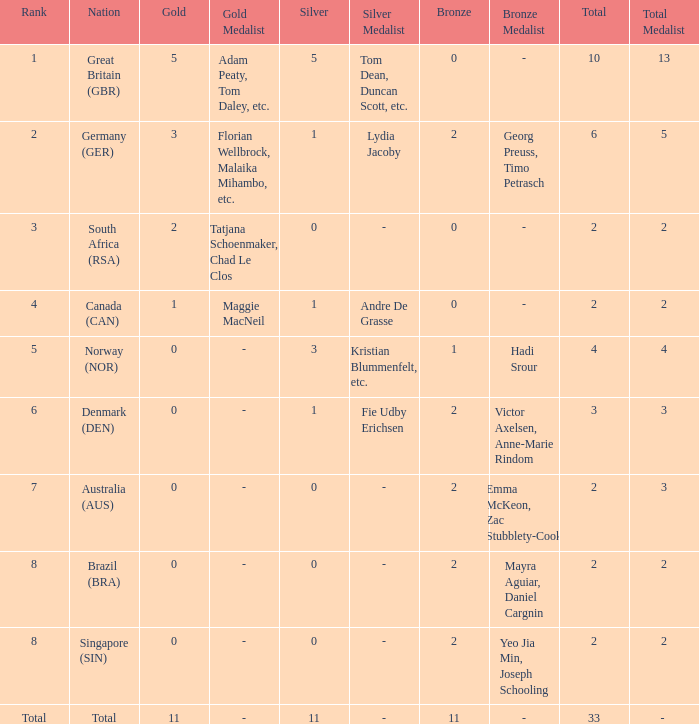Could you parse the entire table as a dict? {'header': ['Rank', 'Nation', 'Gold', 'Gold Medalist', 'Silver', 'Silver Medalist', 'Bronze', 'Bronze Medalist', 'Total', 'Total Medalist'], 'rows': [['1', 'Great Britain (GBR)', '5', 'Adam Peaty, Tom Daley, etc.', '5', 'Tom Dean, Duncan Scott, etc.', '0', '-', '10', '13'], ['2', 'Germany (GER)', '3', 'Florian Wellbrock, Malaika Mihambo, etc.', '1', 'Lydia Jacoby', '2', 'Georg Preuss, Timo Petrasch', '6', '5'], ['3', 'South Africa (RSA)', '2', 'Tatjana Schoenmaker, Chad Le Clos', '0', '-', '0', '-', '2', '2'], ['4', 'Canada (CAN)', '1', 'Maggie MacNeil', '1', 'Andre De Grasse', '0', '-', '2', '2'], ['5', 'Norway (NOR)', '0', '-', '3', 'Kristian Blummenfelt, etc.', '1', 'Hadi Srour', '4', '4'], ['6', 'Denmark (DEN)', '0', '-', '1', 'Fie Udby Erichsen', '2', 'Victor Axelsen, Anne-Marie Rindom', '3', '3'], ['7', 'Australia (AUS)', '0', '-', '0', '-', '2', 'Emma McKeon, Zac Stubblety-Cook', '2', '3'], ['8', 'Brazil (BRA)', '0', '-', '0', '-', '2', 'Mayra Aguiar, Daniel Cargnin', '2', '2'], ['8', 'Singapore (SIN)', '0', '-', '0', '-', '2', 'Yeo Jia Min, Joseph Schooling', '2', '2'], ['Total', 'Total', '11', '-', '11', '-', '11', '-', '33', '- ']]} What is the total when the nation is brazil (bra) and bronze is more than 2? None. 